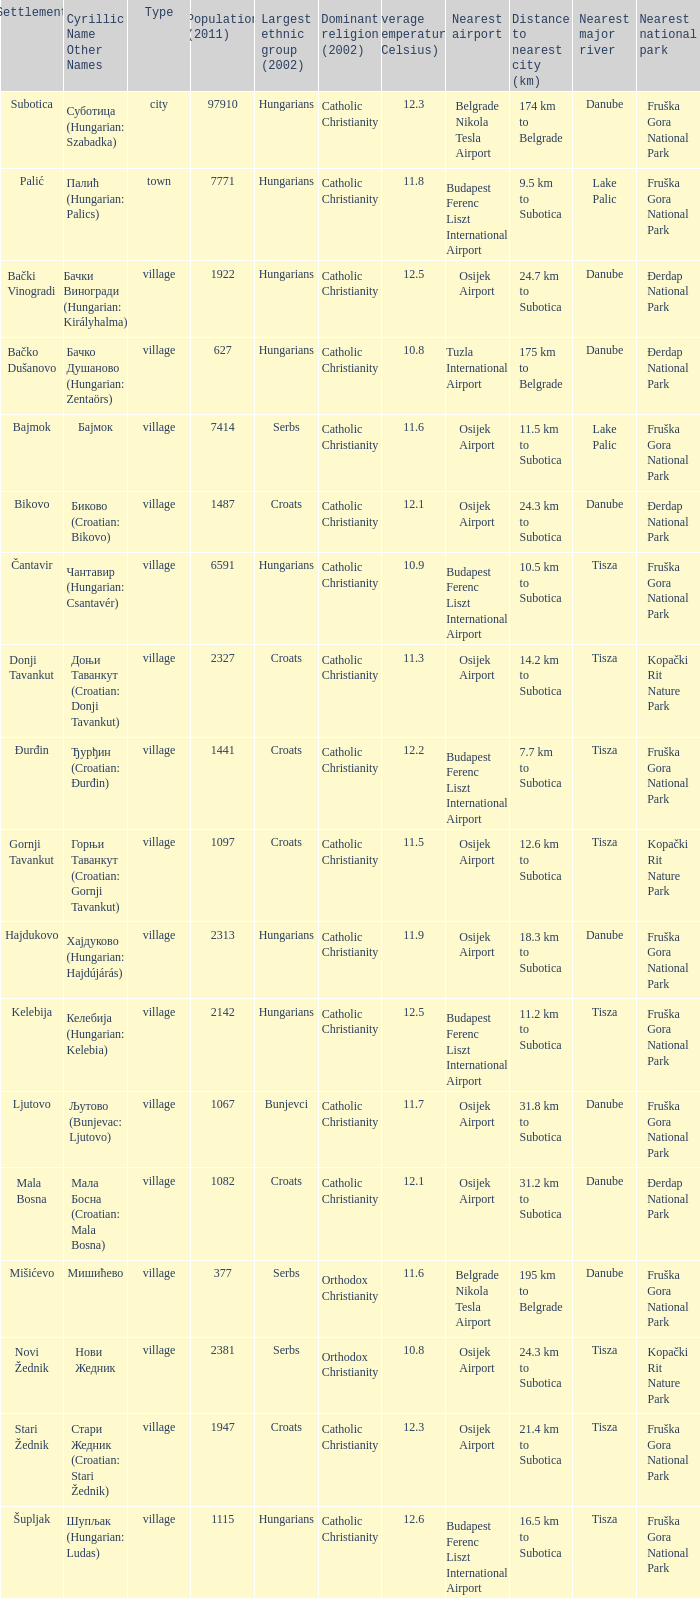What are the cyrillic and other names of the settlement whose population is 6591? Чантавир (Hungarian: Csantavér). 